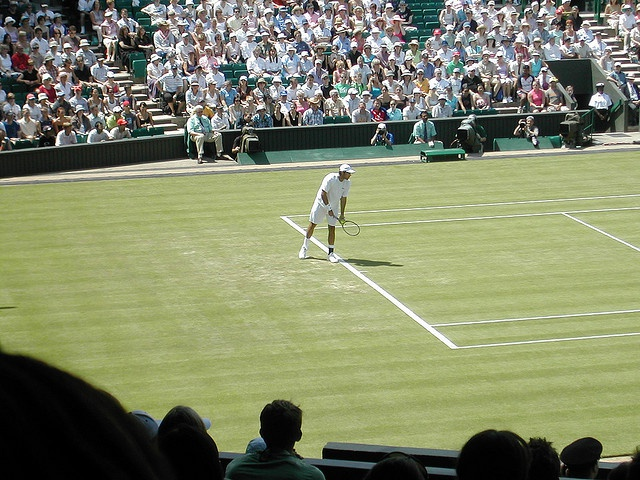Describe the objects in this image and their specific colors. I can see people in black, gray, darkgray, and white tones, people in black, tan, and teal tones, people in black, darkgreen, and gray tones, people in black, darkgray, white, olive, and gray tones, and people in black, gray, purple, and teal tones in this image. 